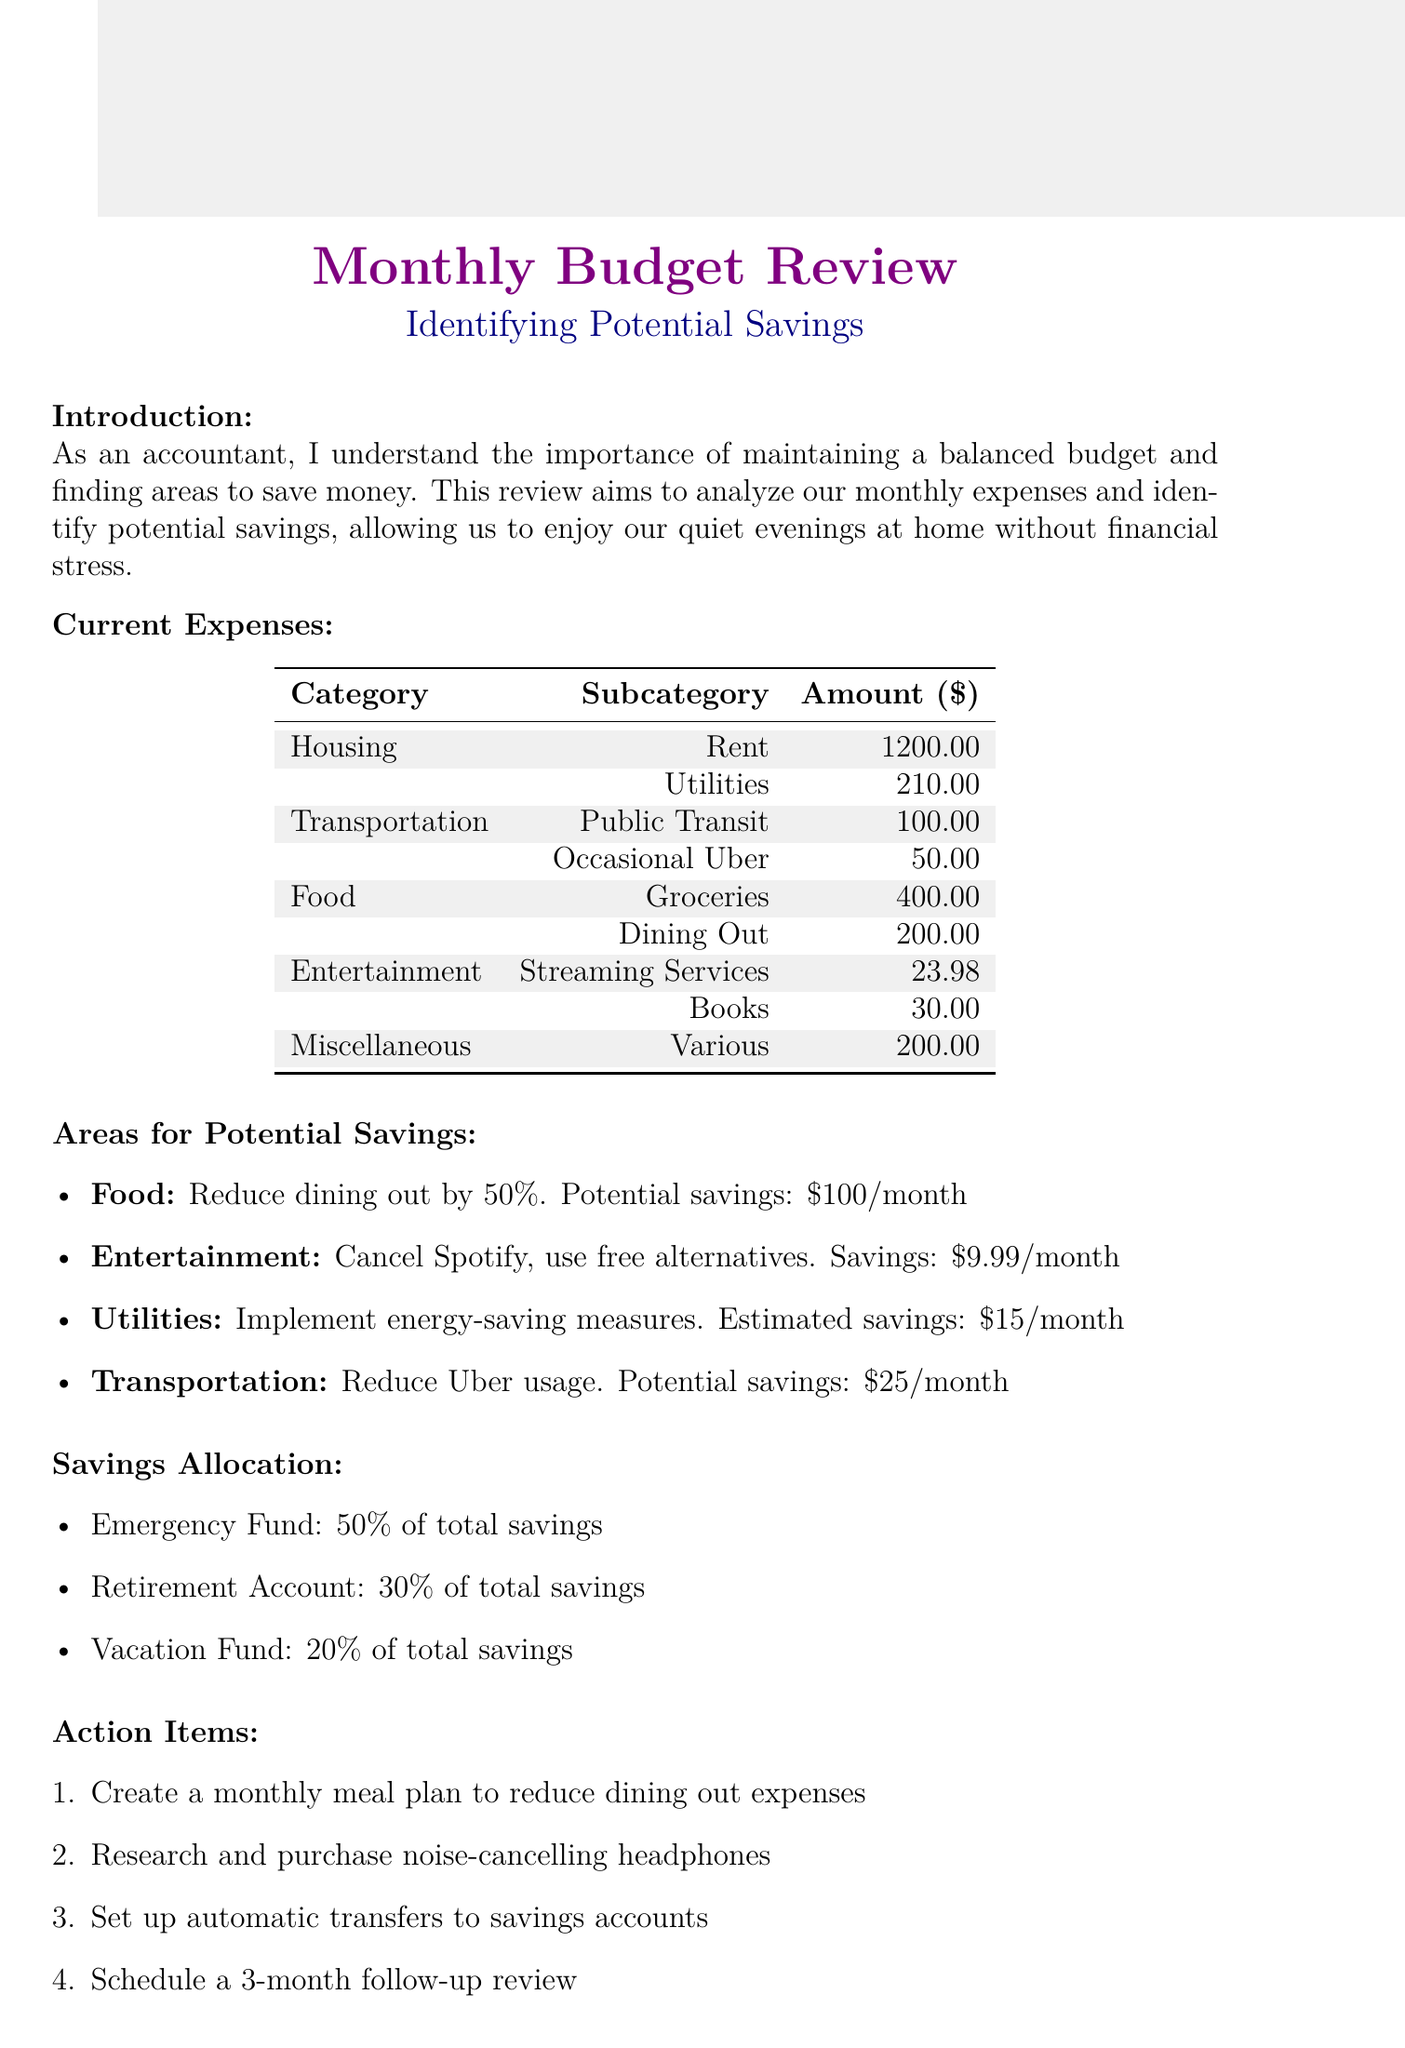What is the total amount for Housing expenses? The total amount for Housing expenses is the sum of rent and utilities, which is 1200 plus 210.
Answer: 1410 How much can be potentially saved from dining out expenses? The potential savings from reducing dining out expenses by 50% is stated in the document.
Answer: 100 What are the total monthly food expenses? The total monthly food expenses can be calculated by adding groceries and dining out, which is 400 plus 200.
Answer: 600 Which entertainment subscription is suggested to be canceled? The document specifies a suggestion to cancel a particular entertainment subscription to save money.
Answer: Spotify What percentage of total savings is allocated to the emergency fund? The allocation for the emergency fund is detailed in the savings allocation section of the document.
Answer: 50 percent What is the potential savings from implementing energy-saving measures? The document provides a specific figure for potential utilities savings from energy-saving measures.
Answer: 15 What is one proposed action item related to dining expenses? The document outlines specific action items to address dining expenses among other areas.
Answer: Create a meal plan How much can potentially be saved by reducing Uber usage? The amount of potential savings from reducing Uber usage is provided in the areas for savings section.
Answer: 25 What is the total potential savings per month by implementing all suggested changes? The conclusion summarizes the total potential savings from all suggested changes in the document.
Answer: 150 What is the purpose of this memo? The purpose of the memo is explicitly stated in the introduction section, summarizing its overall intent.
Answer: To analyze monthly expenses and identify potential savings 